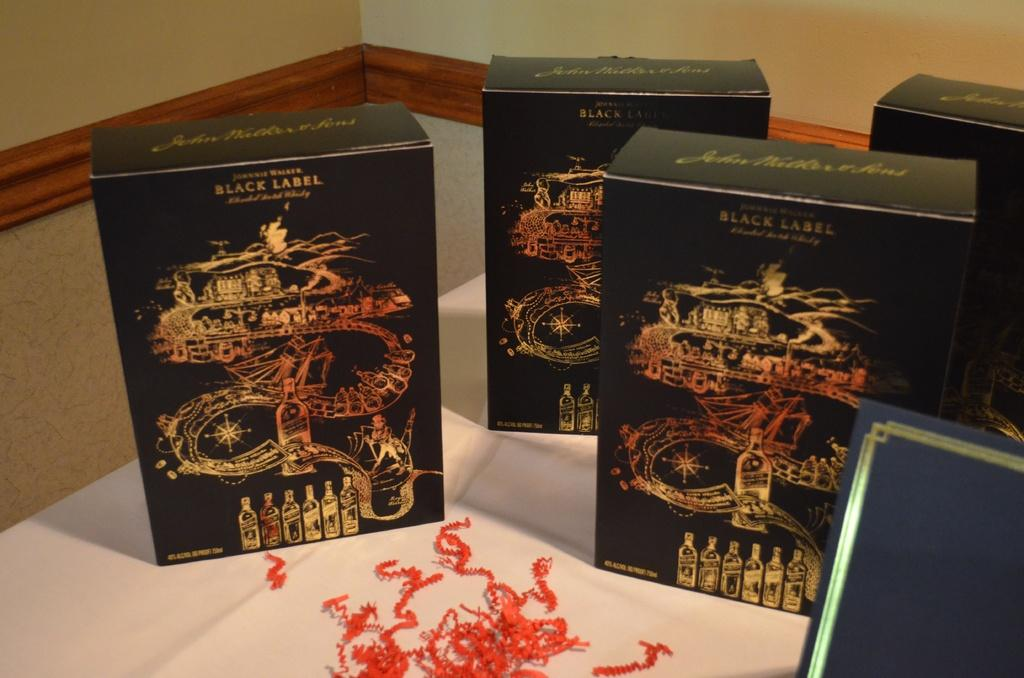<image>
Present a compact description of the photo's key features. Four boxes of Jonnie Walker Black Label are on a table. 